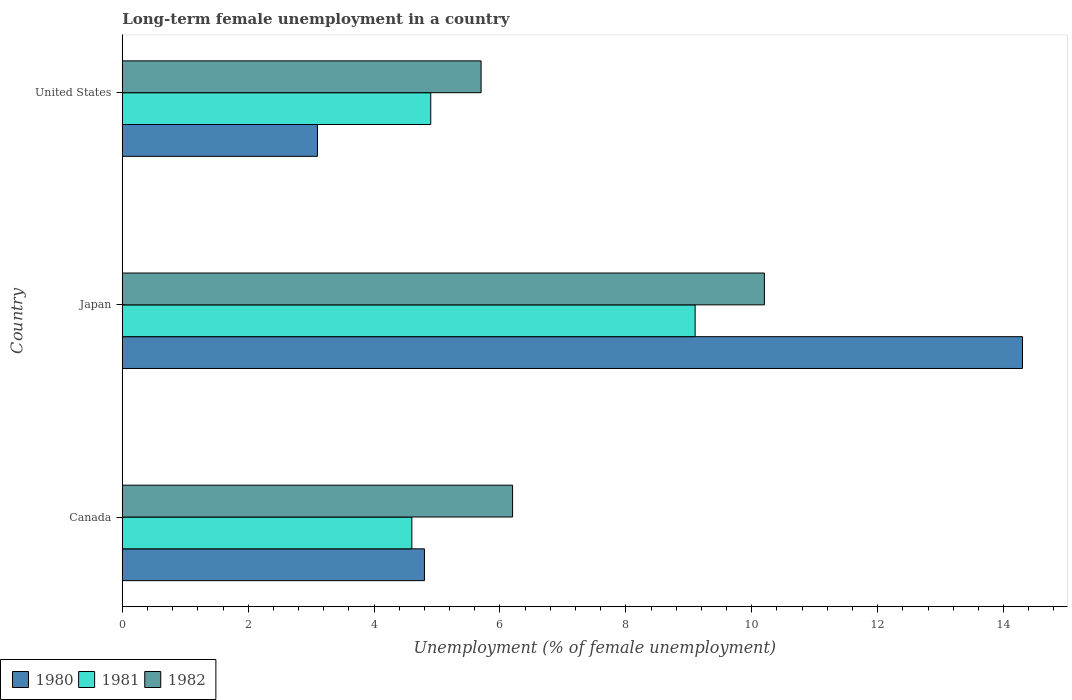What is the label of the 1st group of bars from the top?
Offer a very short reply. United States. In how many cases, is the number of bars for a given country not equal to the number of legend labels?
Make the answer very short. 0. What is the percentage of long-term unemployed female population in 1982 in Canada?
Offer a very short reply. 6.2. Across all countries, what is the maximum percentage of long-term unemployed female population in 1980?
Provide a short and direct response. 14.3. Across all countries, what is the minimum percentage of long-term unemployed female population in 1981?
Make the answer very short. 4.6. In which country was the percentage of long-term unemployed female population in 1980 maximum?
Keep it short and to the point. Japan. In which country was the percentage of long-term unemployed female population in 1981 minimum?
Your answer should be very brief. Canada. What is the total percentage of long-term unemployed female population in 1980 in the graph?
Make the answer very short. 22.2. What is the difference between the percentage of long-term unemployed female population in 1980 in Canada and that in Japan?
Offer a very short reply. -9.5. What is the difference between the percentage of long-term unemployed female population in 1981 in Japan and the percentage of long-term unemployed female population in 1980 in Canada?
Your answer should be very brief. 4.3. What is the average percentage of long-term unemployed female population in 1981 per country?
Your answer should be very brief. 6.2. What is the difference between the percentage of long-term unemployed female population in 1981 and percentage of long-term unemployed female population in 1980 in Japan?
Ensure brevity in your answer.  -5.2. What is the ratio of the percentage of long-term unemployed female population in 1981 in Canada to that in Japan?
Your response must be concise. 0.51. Is the percentage of long-term unemployed female population in 1980 in Canada less than that in United States?
Give a very brief answer. No. What is the difference between the highest and the second highest percentage of long-term unemployed female population in 1981?
Your answer should be compact. 4.2. What is the difference between the highest and the lowest percentage of long-term unemployed female population in 1982?
Make the answer very short. 4.5. Is the sum of the percentage of long-term unemployed female population in 1982 in Canada and United States greater than the maximum percentage of long-term unemployed female population in 1980 across all countries?
Your answer should be very brief. No. What does the 1st bar from the top in United States represents?
Provide a short and direct response. 1982. What does the 2nd bar from the bottom in Japan represents?
Keep it short and to the point. 1981. Is it the case that in every country, the sum of the percentage of long-term unemployed female population in 1980 and percentage of long-term unemployed female population in 1982 is greater than the percentage of long-term unemployed female population in 1981?
Your answer should be compact. Yes. Are all the bars in the graph horizontal?
Your response must be concise. Yes. How many countries are there in the graph?
Give a very brief answer. 3. Are the values on the major ticks of X-axis written in scientific E-notation?
Provide a succinct answer. No. Does the graph contain any zero values?
Your answer should be compact. No. What is the title of the graph?
Offer a very short reply. Long-term female unemployment in a country. Does "2008" appear as one of the legend labels in the graph?
Your answer should be compact. No. What is the label or title of the X-axis?
Provide a succinct answer. Unemployment (% of female unemployment). What is the Unemployment (% of female unemployment) in 1980 in Canada?
Ensure brevity in your answer.  4.8. What is the Unemployment (% of female unemployment) of 1981 in Canada?
Your answer should be compact. 4.6. What is the Unemployment (% of female unemployment) in 1982 in Canada?
Keep it short and to the point. 6.2. What is the Unemployment (% of female unemployment) in 1980 in Japan?
Your answer should be compact. 14.3. What is the Unemployment (% of female unemployment) of 1981 in Japan?
Keep it short and to the point. 9.1. What is the Unemployment (% of female unemployment) in 1982 in Japan?
Provide a succinct answer. 10.2. What is the Unemployment (% of female unemployment) of 1980 in United States?
Provide a short and direct response. 3.1. What is the Unemployment (% of female unemployment) in 1981 in United States?
Give a very brief answer. 4.9. What is the Unemployment (% of female unemployment) in 1982 in United States?
Your answer should be very brief. 5.7. Across all countries, what is the maximum Unemployment (% of female unemployment) in 1980?
Offer a very short reply. 14.3. Across all countries, what is the maximum Unemployment (% of female unemployment) of 1981?
Your answer should be very brief. 9.1. Across all countries, what is the maximum Unemployment (% of female unemployment) of 1982?
Provide a succinct answer. 10.2. Across all countries, what is the minimum Unemployment (% of female unemployment) in 1980?
Offer a terse response. 3.1. Across all countries, what is the minimum Unemployment (% of female unemployment) of 1981?
Provide a succinct answer. 4.6. Across all countries, what is the minimum Unemployment (% of female unemployment) of 1982?
Provide a short and direct response. 5.7. What is the total Unemployment (% of female unemployment) in 1981 in the graph?
Offer a very short reply. 18.6. What is the total Unemployment (% of female unemployment) of 1982 in the graph?
Give a very brief answer. 22.1. What is the difference between the Unemployment (% of female unemployment) in 1981 in Canada and that in Japan?
Provide a succinct answer. -4.5. What is the difference between the Unemployment (% of female unemployment) in 1980 in Canada and that in United States?
Your answer should be very brief. 1.7. What is the difference between the Unemployment (% of female unemployment) in 1982 in Canada and that in United States?
Offer a very short reply. 0.5. What is the difference between the Unemployment (% of female unemployment) in 1980 in Japan and that in United States?
Give a very brief answer. 11.2. What is the difference between the Unemployment (% of female unemployment) of 1980 in Canada and the Unemployment (% of female unemployment) of 1981 in Japan?
Provide a succinct answer. -4.3. What is the difference between the Unemployment (% of female unemployment) of 1980 in Canada and the Unemployment (% of female unemployment) of 1982 in Japan?
Your answer should be very brief. -5.4. What is the difference between the Unemployment (% of female unemployment) of 1981 in Canada and the Unemployment (% of female unemployment) of 1982 in Japan?
Offer a terse response. -5.6. What is the difference between the Unemployment (% of female unemployment) of 1980 in Canada and the Unemployment (% of female unemployment) of 1981 in United States?
Provide a succinct answer. -0.1. What is the difference between the Unemployment (% of female unemployment) of 1981 in Canada and the Unemployment (% of female unemployment) of 1982 in United States?
Offer a terse response. -1.1. What is the difference between the Unemployment (% of female unemployment) in 1980 in Japan and the Unemployment (% of female unemployment) in 1981 in United States?
Give a very brief answer. 9.4. What is the difference between the Unemployment (% of female unemployment) of 1980 in Japan and the Unemployment (% of female unemployment) of 1982 in United States?
Keep it short and to the point. 8.6. What is the average Unemployment (% of female unemployment) in 1980 per country?
Keep it short and to the point. 7.4. What is the average Unemployment (% of female unemployment) in 1981 per country?
Your response must be concise. 6.2. What is the average Unemployment (% of female unemployment) in 1982 per country?
Offer a very short reply. 7.37. What is the difference between the Unemployment (% of female unemployment) of 1980 and Unemployment (% of female unemployment) of 1982 in Canada?
Your answer should be very brief. -1.4. What is the difference between the Unemployment (% of female unemployment) in 1980 and Unemployment (% of female unemployment) in 1982 in Japan?
Provide a short and direct response. 4.1. What is the difference between the Unemployment (% of female unemployment) of 1981 and Unemployment (% of female unemployment) of 1982 in Japan?
Offer a very short reply. -1.1. What is the difference between the Unemployment (% of female unemployment) of 1981 and Unemployment (% of female unemployment) of 1982 in United States?
Keep it short and to the point. -0.8. What is the ratio of the Unemployment (% of female unemployment) of 1980 in Canada to that in Japan?
Offer a very short reply. 0.34. What is the ratio of the Unemployment (% of female unemployment) in 1981 in Canada to that in Japan?
Your answer should be compact. 0.51. What is the ratio of the Unemployment (% of female unemployment) in 1982 in Canada to that in Japan?
Offer a very short reply. 0.61. What is the ratio of the Unemployment (% of female unemployment) in 1980 in Canada to that in United States?
Give a very brief answer. 1.55. What is the ratio of the Unemployment (% of female unemployment) in 1981 in Canada to that in United States?
Your response must be concise. 0.94. What is the ratio of the Unemployment (% of female unemployment) in 1982 in Canada to that in United States?
Your answer should be very brief. 1.09. What is the ratio of the Unemployment (% of female unemployment) of 1980 in Japan to that in United States?
Keep it short and to the point. 4.61. What is the ratio of the Unemployment (% of female unemployment) in 1981 in Japan to that in United States?
Give a very brief answer. 1.86. What is the ratio of the Unemployment (% of female unemployment) in 1982 in Japan to that in United States?
Keep it short and to the point. 1.79. What is the difference between the highest and the second highest Unemployment (% of female unemployment) in 1981?
Provide a succinct answer. 4.2. What is the difference between the highest and the lowest Unemployment (% of female unemployment) of 1981?
Make the answer very short. 4.5. What is the difference between the highest and the lowest Unemployment (% of female unemployment) in 1982?
Your answer should be very brief. 4.5. 